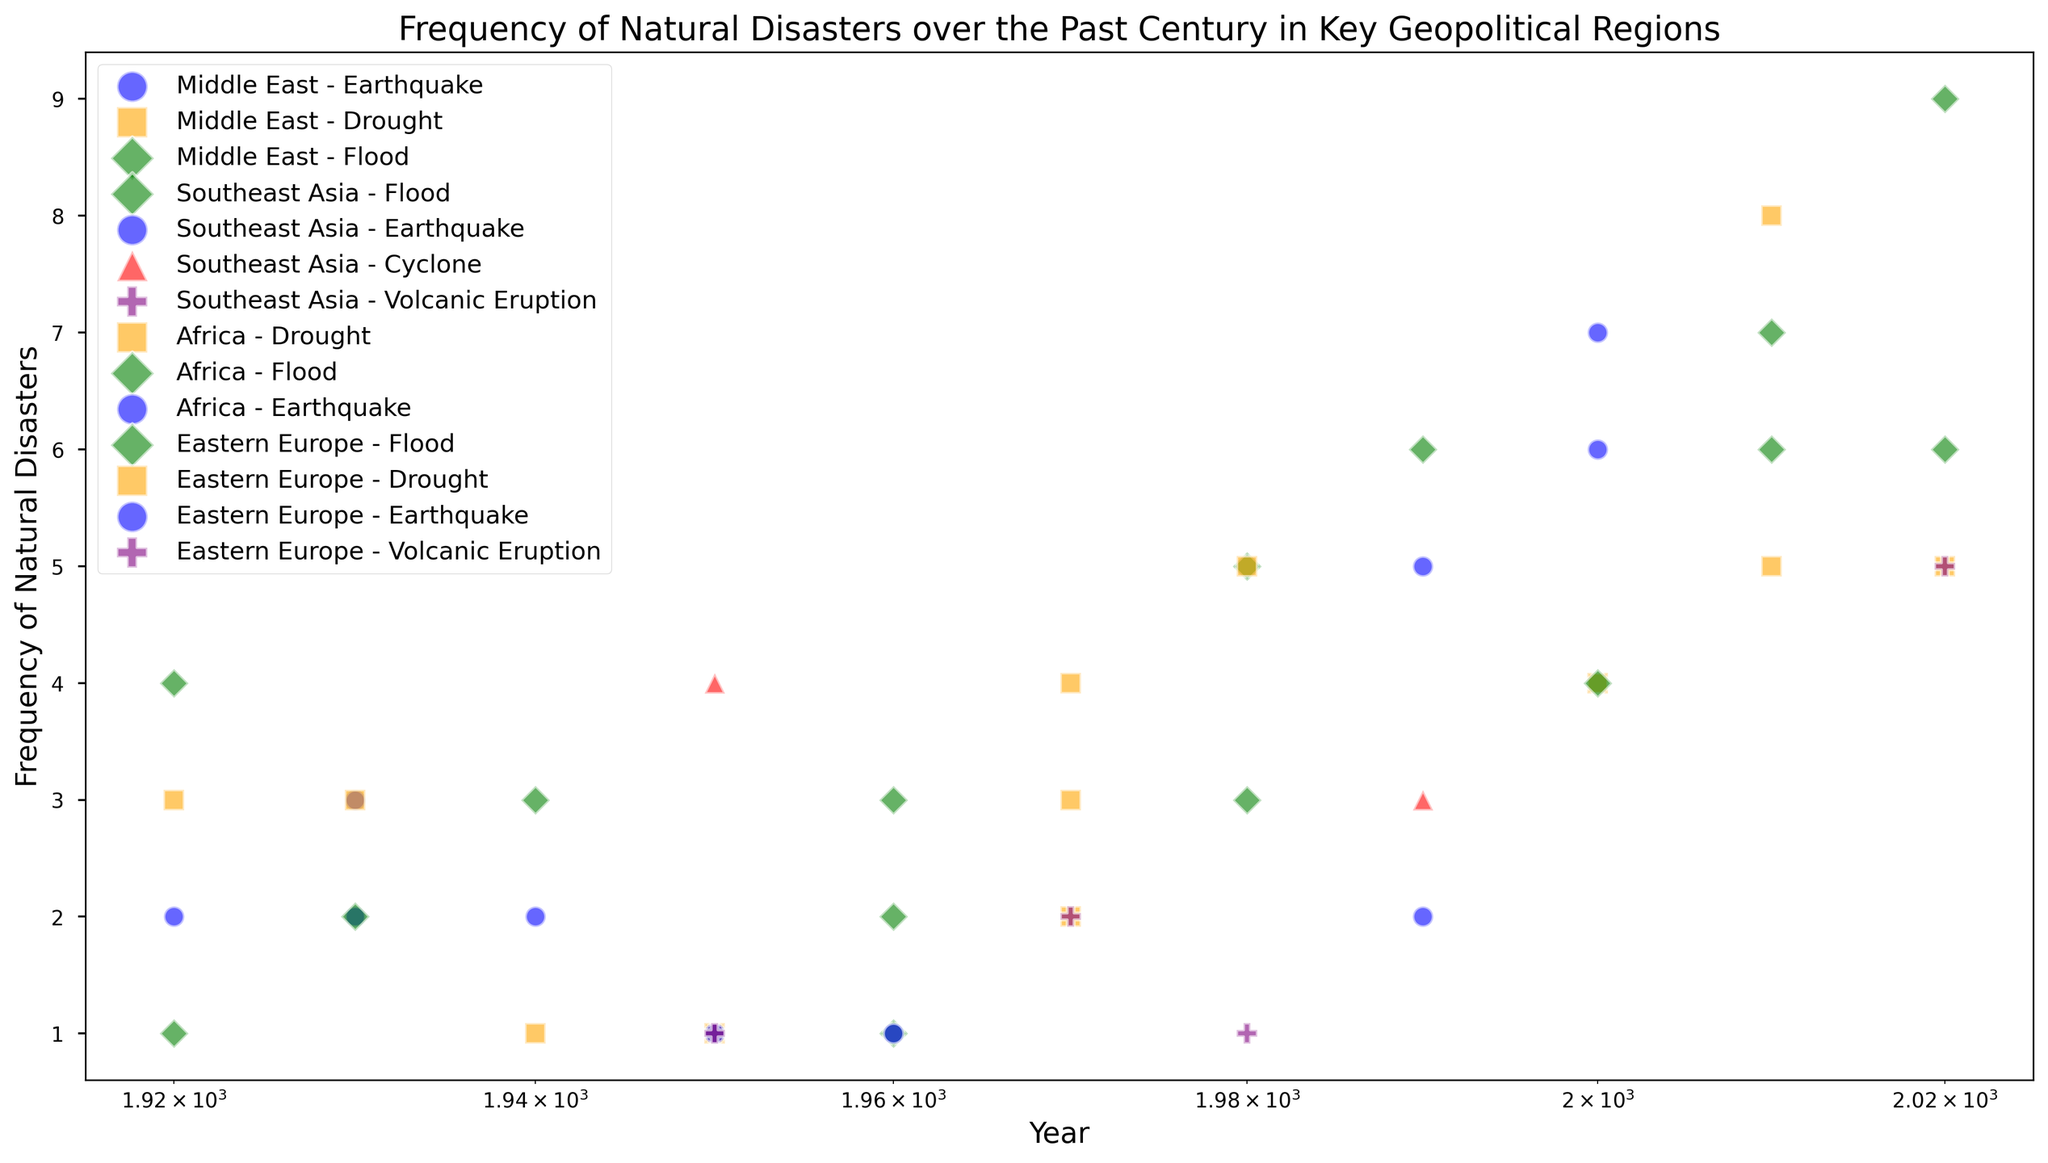What is the average frequency of floods in the Middle East over the observed years? First, identify the frequency of floods in the Middle East: 1 (1960), 3 (1980), and 6 (2010). Sum these values: 1 + 3 + 6 = 10. Now, divide by the number of data points: 10 / 3 = 3.33.
Answer: 3.33 Which region experienced the highest frequency of earthquakes by 2000? Compare the frequency of earthquakes for each region by 2000. Middle East has 5 (1990), Southeast Asia has 6 (2000), Africa has 1 (1950), and Eastern Europe has 2 (1990). Southeast Asia has the highest frequency.
Answer: Southeast Asia What is the total frequency of droughts in Africa across all observed years? Identify all drought frequencies in Africa: 3 (1920), 1 (1940), 4 (1970), 5 (1980), and 8 (2010). Sum these values: 3 + 1 + 4 + 5 + 8 = 21.
Answer: 21 Between Southeast Asia and Eastern Europe, which region had more frequent volcanic eruptions by 2020? Check the frequency of volcanic eruptions: Southeast Asia has 2 (1970) and 5 (2020) while Eastern Europe has 1 (1950) and 1 (1980). Sum the values for each: Southeast Asia (2 + 5 = 7) and Eastern Europe (1 + 1 = 2). Southeast Asia had more frequent volcanic eruptions by 2020.
Answer: Southeast Asia What is the primary color representing droughts on the plot? Observe the marker color used for droughts in different regions. The color is consistent across all regions for droughts, which is orange.
Answer: Orange How many regions experienced floods in the decade 2020? Look for flood data points in 2020. Identify that Middle East, Africa, and Eastern Europe experienced floods in 2020. That's 3 regions.
Answer: 3 In which year did the Middle East experience the highest frequency of natural disasters, and which type was it? Review the frequency data for each type of disaster in the Middle East across the years and identify the highest frequency. In 2010, there were 6 floods, which is the highest frequency recorded.
Answer: 2010, Flood Which natural disaster type showed an increasing trend in frequency in Africa over the century? Review the frequency data for each natural disaster type in Africa from 1920 to 2020. Identify that floods increased progressively: 2 (1930), 3 (1960), 6 (1990), 9 (2020). Floods show an increasing trend.
Answer: Flood Calculate the total frequency of volcanic eruptions observed in all regions combined. Sum the frequency of volcanic eruptions from all regions: Southeast Asia (2 in 1970 and 5 in 2020), Eastern Europe (1 in 1950 and 1 in 1980). The total is 2 + 5 + 1 + 1 = 9.
Answer: 9 Which region had the most diverse types of natural disasters recorded? Compare the number of different disaster types per region. Middle East has Earthquake, Drought, Flood; Southeast Asia has Earthquake, Flood, Cyclone, Volcanic Eruption; Africa has Drought, Flood, Earthquake; Eastern Europe has Flood, Drought, Earthquake, Volcanic Eruption. Southeast Asia and Eastern Europe both recorded 4 types, which is the most diverse.
Answer: Southeast Asia, Eastern Europe 